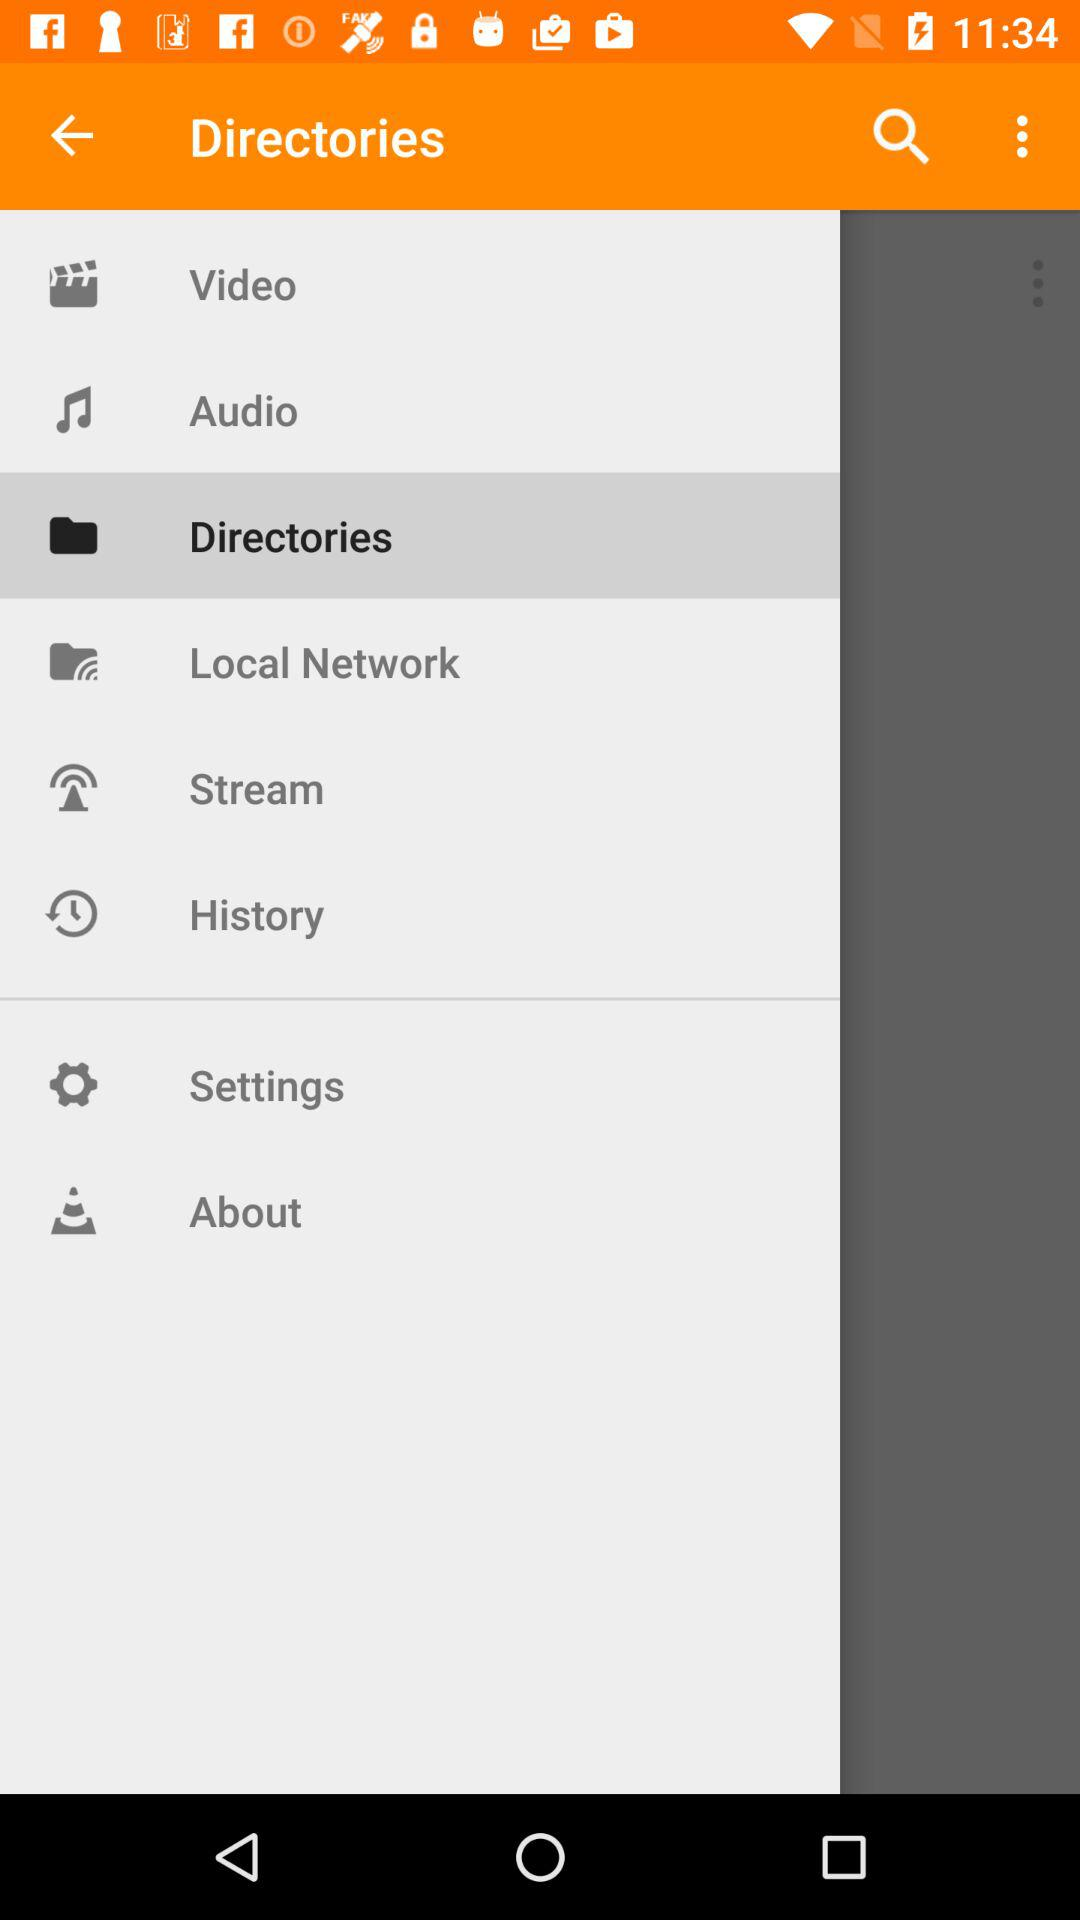What is the application name?
When the provided information is insufficient, respond with <no answer>. <no answer> 